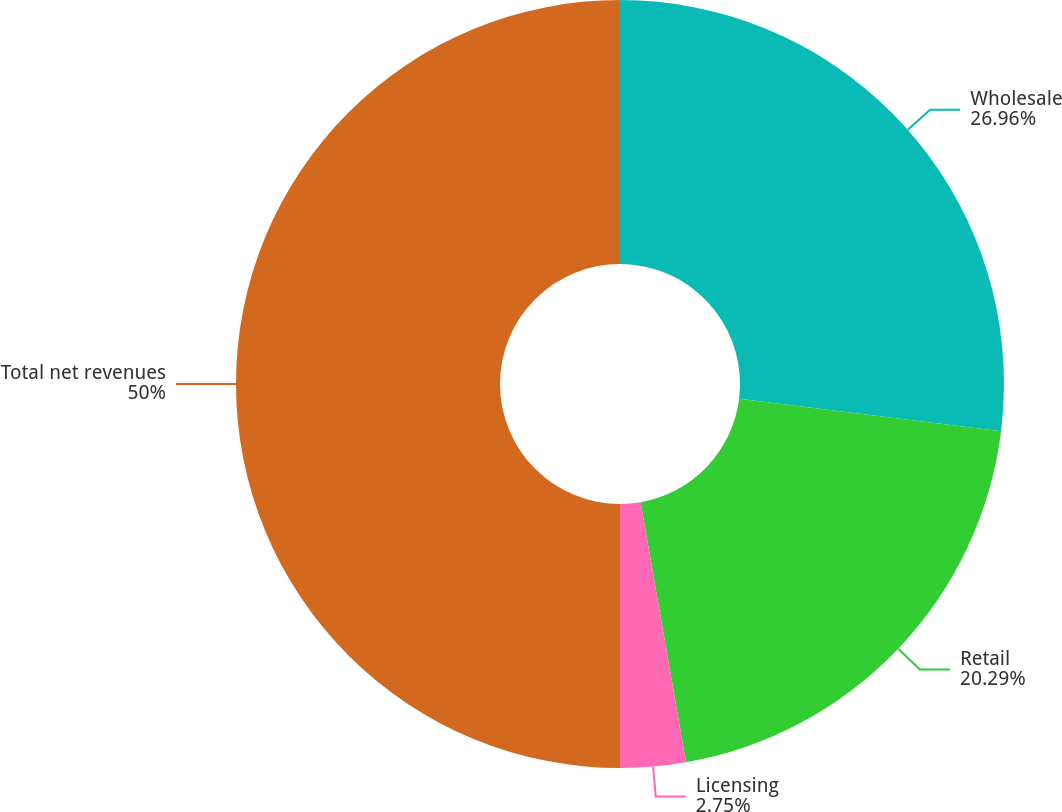<chart> <loc_0><loc_0><loc_500><loc_500><pie_chart><fcel>Wholesale<fcel>Retail<fcel>Licensing<fcel>Total net revenues<nl><fcel>26.96%<fcel>20.29%<fcel>2.75%<fcel>50.0%<nl></chart> 